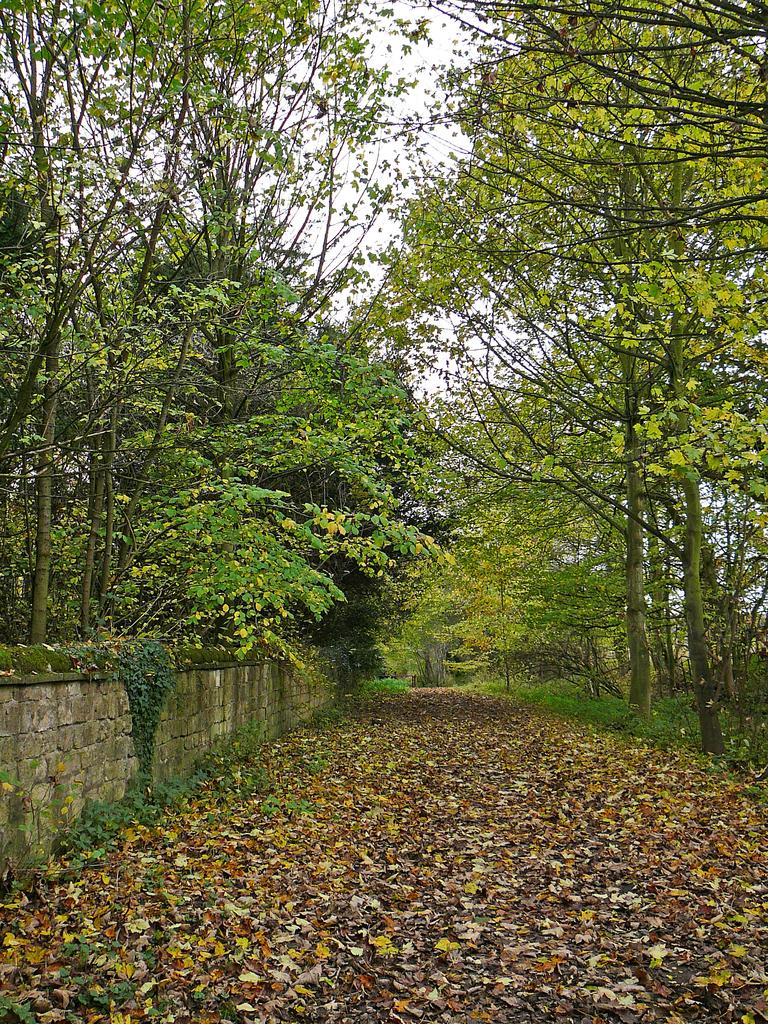What type of vegetation can be seen in the image? There are trees in the image. What structure is visible in the image? There is a wall in the image. What is present on the ground in the image? Dry leaves are present on the ground. What is the color of the sky in the image? The sky is white in color. Is there a campfire visible in the image? There is no campfire present in the image. What type of vacation destination is depicted in the image? The image does not depict a specific vacation destination; it only shows trees, a wall, dry leaves, and a white sky. 